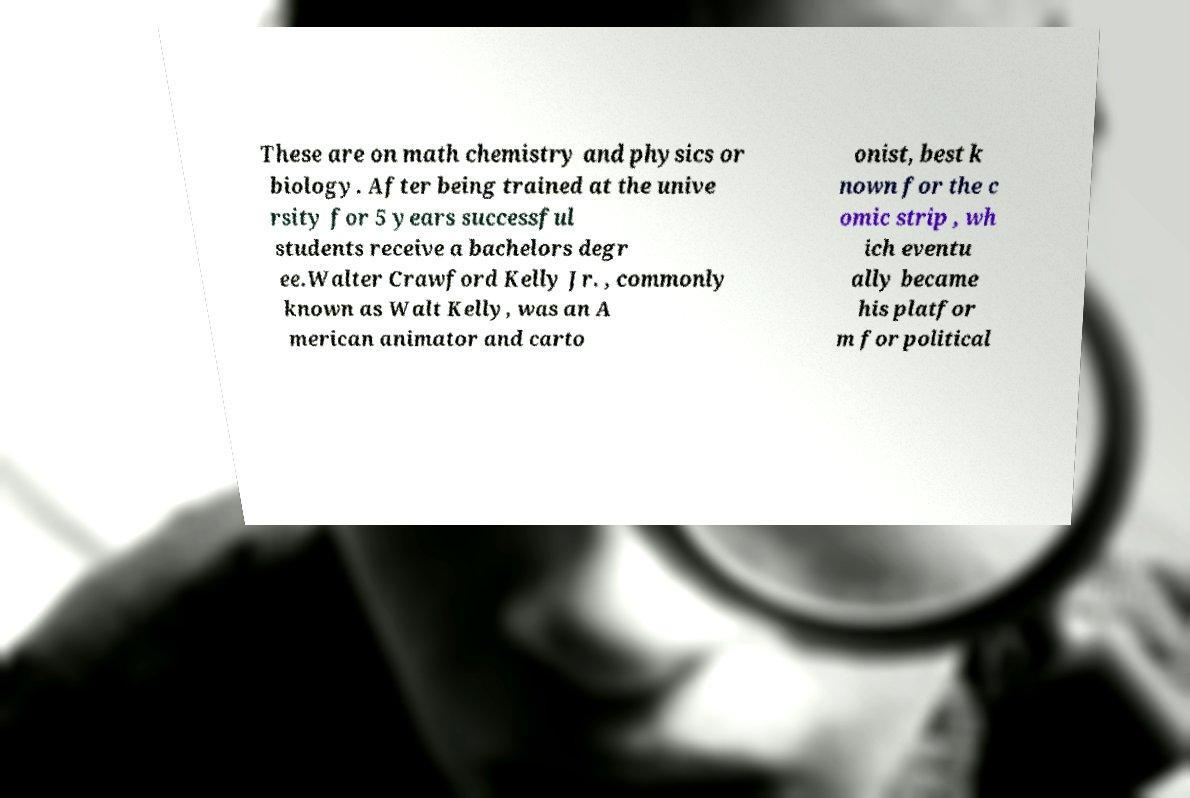I need the written content from this picture converted into text. Can you do that? These are on math chemistry and physics or biology. After being trained at the unive rsity for 5 years successful students receive a bachelors degr ee.Walter Crawford Kelly Jr. , commonly known as Walt Kelly, was an A merican animator and carto onist, best k nown for the c omic strip , wh ich eventu ally became his platfor m for political 